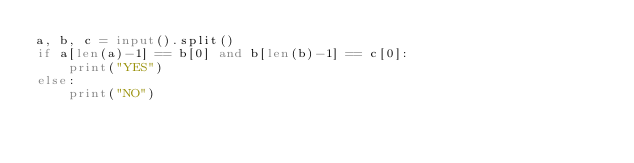Convert code to text. <code><loc_0><loc_0><loc_500><loc_500><_Python_>a, b, c = input().split()
if a[len(a)-1] == b[0] and b[len(b)-1] == c[0]:
    print("YES")
else:
    print("NO")
</code> 